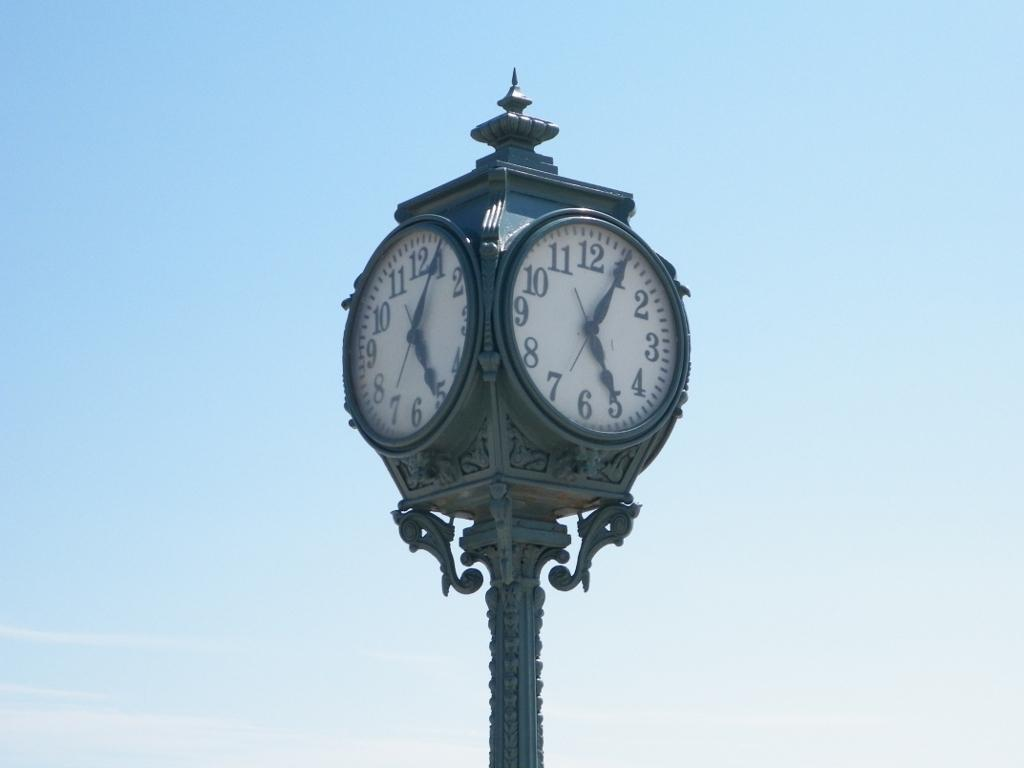<image>
Write a terse but informative summary of the picture. Large clock that has the hands on the numbers 1 and 5. 